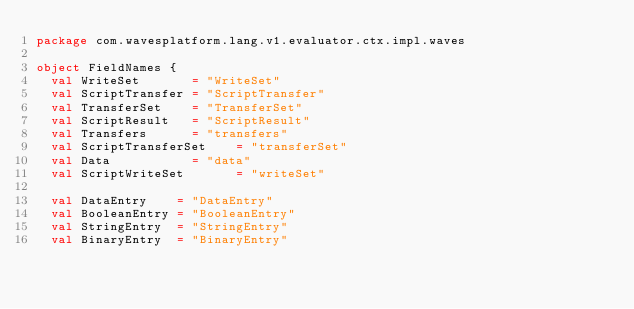Convert code to text. <code><loc_0><loc_0><loc_500><loc_500><_Scala_>package com.wavesplatform.lang.v1.evaluator.ctx.impl.waves

object FieldNames {
  val WriteSet       = "WriteSet"
  val ScriptTransfer = "ScriptTransfer"
  val TransferSet    = "TransferSet"
  val ScriptResult   = "ScriptResult"
  val Transfers      = "transfers"
  val ScriptTransferSet    = "transferSet"
  val Data           = "data"
  val ScriptWriteSet       = "writeSet"

  val DataEntry    = "DataEntry"
  val BooleanEntry = "BooleanEntry"
  val StringEntry  = "StringEntry"
  val BinaryEntry  = "BinaryEntry"</code> 